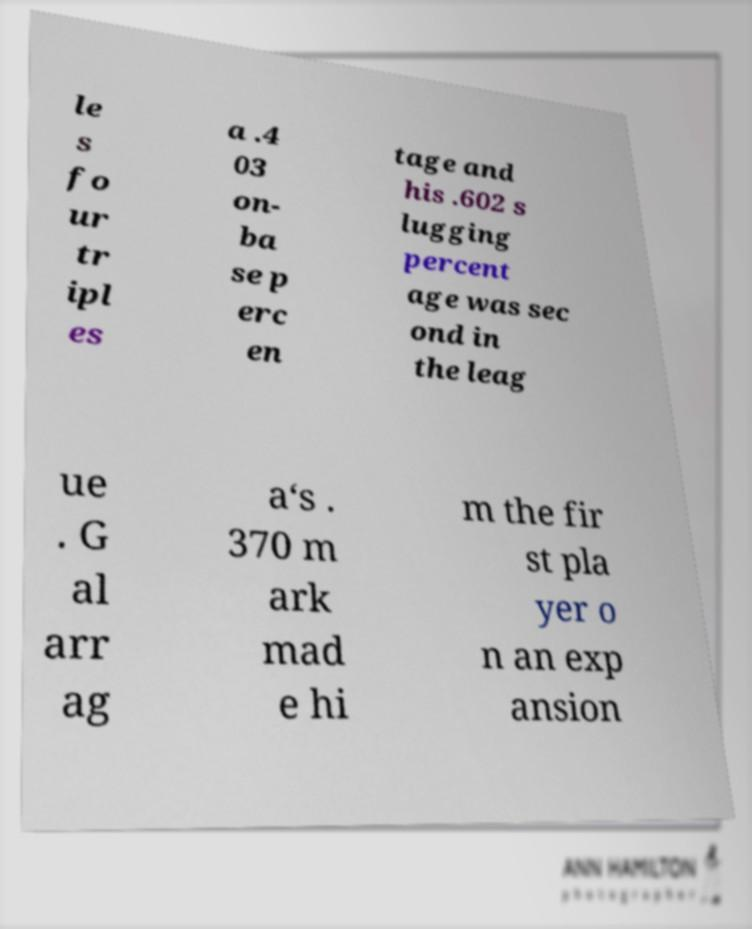For documentation purposes, I need the text within this image transcribed. Could you provide that? le s fo ur tr ipl es a .4 03 on- ba se p erc en tage and his .602 s lugging percent age was sec ond in the leag ue . G al arr ag a‘s . 370 m ark mad e hi m the fir st pla yer o n an exp ansion 